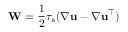Convert formula to latex. <formula><loc_0><loc_0><loc_500><loc_500>W = \frac { 1 } { 2 } \tau _ { s } ( \nabla u - \nabla u ^ { \top } )</formula> 